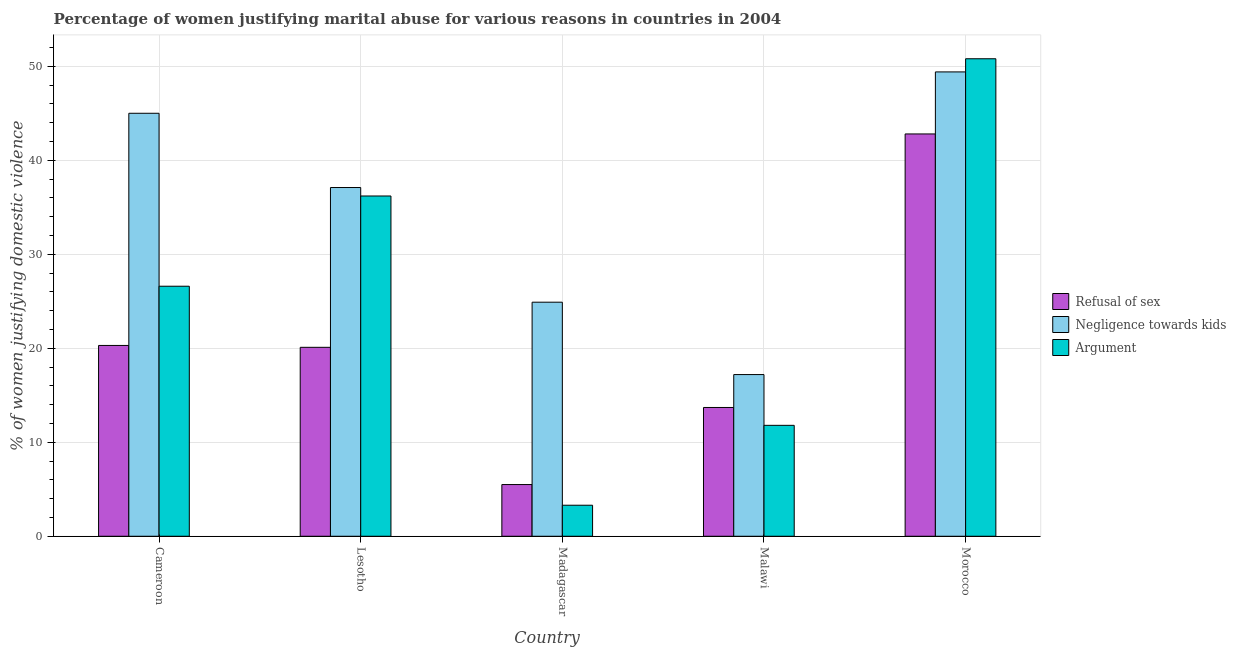How many different coloured bars are there?
Your answer should be compact. 3. How many groups of bars are there?
Ensure brevity in your answer.  5. Are the number of bars on each tick of the X-axis equal?
Your answer should be very brief. Yes. How many bars are there on the 4th tick from the right?
Offer a terse response. 3. What is the label of the 2nd group of bars from the left?
Your answer should be compact. Lesotho. What is the percentage of women justifying domestic violence due to refusal of sex in Morocco?
Give a very brief answer. 42.8. Across all countries, what is the maximum percentage of women justifying domestic violence due to negligence towards kids?
Offer a very short reply. 49.4. In which country was the percentage of women justifying domestic violence due to refusal of sex maximum?
Make the answer very short. Morocco. In which country was the percentage of women justifying domestic violence due to refusal of sex minimum?
Offer a terse response. Madagascar. What is the total percentage of women justifying domestic violence due to negligence towards kids in the graph?
Give a very brief answer. 173.6. What is the difference between the percentage of women justifying domestic violence due to negligence towards kids in Lesotho and that in Malawi?
Your answer should be very brief. 19.9. What is the difference between the percentage of women justifying domestic violence due to negligence towards kids in Lesotho and the percentage of women justifying domestic violence due to refusal of sex in Malawi?
Provide a succinct answer. 23.4. What is the average percentage of women justifying domestic violence due to refusal of sex per country?
Keep it short and to the point. 20.48. In how many countries, is the percentage of women justifying domestic violence due to arguments greater than 50 %?
Your answer should be compact. 1. What is the ratio of the percentage of women justifying domestic violence due to arguments in Lesotho to that in Malawi?
Give a very brief answer. 3.07. What is the difference between the highest and the second highest percentage of women justifying domestic violence due to refusal of sex?
Give a very brief answer. 22.5. What is the difference between the highest and the lowest percentage of women justifying domestic violence due to refusal of sex?
Your answer should be compact. 37.3. In how many countries, is the percentage of women justifying domestic violence due to negligence towards kids greater than the average percentage of women justifying domestic violence due to negligence towards kids taken over all countries?
Provide a succinct answer. 3. Is the sum of the percentage of women justifying domestic violence due to refusal of sex in Madagascar and Morocco greater than the maximum percentage of women justifying domestic violence due to arguments across all countries?
Ensure brevity in your answer.  No. What does the 1st bar from the left in Lesotho represents?
Offer a very short reply. Refusal of sex. What does the 2nd bar from the right in Cameroon represents?
Offer a very short reply. Negligence towards kids. Is it the case that in every country, the sum of the percentage of women justifying domestic violence due to refusal of sex and percentage of women justifying domestic violence due to negligence towards kids is greater than the percentage of women justifying domestic violence due to arguments?
Your answer should be very brief. Yes. How many bars are there?
Ensure brevity in your answer.  15. Are all the bars in the graph horizontal?
Offer a terse response. No. How many countries are there in the graph?
Offer a very short reply. 5. What is the difference between two consecutive major ticks on the Y-axis?
Your response must be concise. 10. Are the values on the major ticks of Y-axis written in scientific E-notation?
Offer a very short reply. No. How many legend labels are there?
Make the answer very short. 3. How are the legend labels stacked?
Provide a short and direct response. Vertical. What is the title of the graph?
Your response must be concise. Percentage of women justifying marital abuse for various reasons in countries in 2004. What is the label or title of the Y-axis?
Provide a succinct answer. % of women justifying domestic violence. What is the % of women justifying domestic violence in Refusal of sex in Cameroon?
Provide a short and direct response. 20.3. What is the % of women justifying domestic violence of Negligence towards kids in Cameroon?
Provide a succinct answer. 45. What is the % of women justifying domestic violence in Argument in Cameroon?
Ensure brevity in your answer.  26.6. What is the % of women justifying domestic violence in Refusal of sex in Lesotho?
Provide a succinct answer. 20.1. What is the % of women justifying domestic violence in Negligence towards kids in Lesotho?
Keep it short and to the point. 37.1. What is the % of women justifying domestic violence of Argument in Lesotho?
Ensure brevity in your answer.  36.2. What is the % of women justifying domestic violence in Refusal of sex in Madagascar?
Ensure brevity in your answer.  5.5. What is the % of women justifying domestic violence of Negligence towards kids in Madagascar?
Your answer should be very brief. 24.9. What is the % of women justifying domestic violence of Refusal of sex in Malawi?
Make the answer very short. 13.7. What is the % of women justifying domestic violence of Negligence towards kids in Malawi?
Offer a terse response. 17.2. What is the % of women justifying domestic violence of Refusal of sex in Morocco?
Give a very brief answer. 42.8. What is the % of women justifying domestic violence of Negligence towards kids in Morocco?
Offer a terse response. 49.4. What is the % of women justifying domestic violence of Argument in Morocco?
Keep it short and to the point. 50.8. Across all countries, what is the maximum % of women justifying domestic violence of Refusal of sex?
Offer a very short reply. 42.8. Across all countries, what is the maximum % of women justifying domestic violence of Negligence towards kids?
Keep it short and to the point. 49.4. Across all countries, what is the maximum % of women justifying domestic violence of Argument?
Offer a terse response. 50.8. Across all countries, what is the minimum % of women justifying domestic violence in Negligence towards kids?
Offer a terse response. 17.2. What is the total % of women justifying domestic violence in Refusal of sex in the graph?
Make the answer very short. 102.4. What is the total % of women justifying domestic violence of Negligence towards kids in the graph?
Your answer should be compact. 173.6. What is the total % of women justifying domestic violence in Argument in the graph?
Your answer should be compact. 128.7. What is the difference between the % of women justifying domestic violence of Refusal of sex in Cameroon and that in Lesotho?
Give a very brief answer. 0.2. What is the difference between the % of women justifying domestic violence of Negligence towards kids in Cameroon and that in Lesotho?
Keep it short and to the point. 7.9. What is the difference between the % of women justifying domestic violence of Argument in Cameroon and that in Lesotho?
Your answer should be compact. -9.6. What is the difference between the % of women justifying domestic violence in Refusal of sex in Cameroon and that in Madagascar?
Offer a very short reply. 14.8. What is the difference between the % of women justifying domestic violence in Negligence towards kids in Cameroon and that in Madagascar?
Make the answer very short. 20.1. What is the difference between the % of women justifying domestic violence of Argument in Cameroon and that in Madagascar?
Your response must be concise. 23.3. What is the difference between the % of women justifying domestic violence in Refusal of sex in Cameroon and that in Malawi?
Keep it short and to the point. 6.6. What is the difference between the % of women justifying domestic violence of Negligence towards kids in Cameroon and that in Malawi?
Your answer should be compact. 27.8. What is the difference between the % of women justifying domestic violence in Argument in Cameroon and that in Malawi?
Provide a short and direct response. 14.8. What is the difference between the % of women justifying domestic violence in Refusal of sex in Cameroon and that in Morocco?
Make the answer very short. -22.5. What is the difference between the % of women justifying domestic violence of Negligence towards kids in Cameroon and that in Morocco?
Offer a terse response. -4.4. What is the difference between the % of women justifying domestic violence in Argument in Cameroon and that in Morocco?
Ensure brevity in your answer.  -24.2. What is the difference between the % of women justifying domestic violence in Refusal of sex in Lesotho and that in Madagascar?
Provide a succinct answer. 14.6. What is the difference between the % of women justifying domestic violence of Argument in Lesotho and that in Madagascar?
Provide a succinct answer. 32.9. What is the difference between the % of women justifying domestic violence in Argument in Lesotho and that in Malawi?
Give a very brief answer. 24.4. What is the difference between the % of women justifying domestic violence of Refusal of sex in Lesotho and that in Morocco?
Ensure brevity in your answer.  -22.7. What is the difference between the % of women justifying domestic violence of Negligence towards kids in Lesotho and that in Morocco?
Your response must be concise. -12.3. What is the difference between the % of women justifying domestic violence of Argument in Lesotho and that in Morocco?
Your answer should be very brief. -14.6. What is the difference between the % of women justifying domestic violence in Refusal of sex in Madagascar and that in Malawi?
Give a very brief answer. -8.2. What is the difference between the % of women justifying domestic violence in Negligence towards kids in Madagascar and that in Malawi?
Ensure brevity in your answer.  7.7. What is the difference between the % of women justifying domestic violence of Refusal of sex in Madagascar and that in Morocco?
Provide a succinct answer. -37.3. What is the difference between the % of women justifying domestic violence of Negligence towards kids in Madagascar and that in Morocco?
Your response must be concise. -24.5. What is the difference between the % of women justifying domestic violence of Argument in Madagascar and that in Morocco?
Keep it short and to the point. -47.5. What is the difference between the % of women justifying domestic violence in Refusal of sex in Malawi and that in Morocco?
Your answer should be very brief. -29.1. What is the difference between the % of women justifying domestic violence of Negligence towards kids in Malawi and that in Morocco?
Offer a terse response. -32.2. What is the difference between the % of women justifying domestic violence of Argument in Malawi and that in Morocco?
Offer a very short reply. -39. What is the difference between the % of women justifying domestic violence of Refusal of sex in Cameroon and the % of women justifying domestic violence of Negligence towards kids in Lesotho?
Offer a terse response. -16.8. What is the difference between the % of women justifying domestic violence of Refusal of sex in Cameroon and the % of women justifying domestic violence of Argument in Lesotho?
Provide a succinct answer. -15.9. What is the difference between the % of women justifying domestic violence in Refusal of sex in Cameroon and the % of women justifying domestic violence in Negligence towards kids in Madagascar?
Offer a terse response. -4.6. What is the difference between the % of women justifying domestic violence of Negligence towards kids in Cameroon and the % of women justifying domestic violence of Argument in Madagascar?
Your answer should be very brief. 41.7. What is the difference between the % of women justifying domestic violence of Negligence towards kids in Cameroon and the % of women justifying domestic violence of Argument in Malawi?
Your answer should be very brief. 33.2. What is the difference between the % of women justifying domestic violence in Refusal of sex in Cameroon and the % of women justifying domestic violence in Negligence towards kids in Morocco?
Provide a short and direct response. -29.1. What is the difference between the % of women justifying domestic violence in Refusal of sex in Cameroon and the % of women justifying domestic violence in Argument in Morocco?
Offer a very short reply. -30.5. What is the difference between the % of women justifying domestic violence in Negligence towards kids in Lesotho and the % of women justifying domestic violence in Argument in Madagascar?
Provide a succinct answer. 33.8. What is the difference between the % of women justifying domestic violence of Refusal of sex in Lesotho and the % of women justifying domestic violence of Negligence towards kids in Malawi?
Offer a very short reply. 2.9. What is the difference between the % of women justifying domestic violence of Negligence towards kids in Lesotho and the % of women justifying domestic violence of Argument in Malawi?
Provide a short and direct response. 25.3. What is the difference between the % of women justifying domestic violence of Refusal of sex in Lesotho and the % of women justifying domestic violence of Negligence towards kids in Morocco?
Your response must be concise. -29.3. What is the difference between the % of women justifying domestic violence in Refusal of sex in Lesotho and the % of women justifying domestic violence in Argument in Morocco?
Keep it short and to the point. -30.7. What is the difference between the % of women justifying domestic violence in Negligence towards kids in Lesotho and the % of women justifying domestic violence in Argument in Morocco?
Give a very brief answer. -13.7. What is the difference between the % of women justifying domestic violence of Refusal of sex in Madagascar and the % of women justifying domestic violence of Negligence towards kids in Morocco?
Provide a succinct answer. -43.9. What is the difference between the % of women justifying domestic violence of Refusal of sex in Madagascar and the % of women justifying domestic violence of Argument in Morocco?
Your answer should be compact. -45.3. What is the difference between the % of women justifying domestic violence in Negligence towards kids in Madagascar and the % of women justifying domestic violence in Argument in Morocco?
Your answer should be compact. -25.9. What is the difference between the % of women justifying domestic violence in Refusal of sex in Malawi and the % of women justifying domestic violence in Negligence towards kids in Morocco?
Your response must be concise. -35.7. What is the difference between the % of women justifying domestic violence in Refusal of sex in Malawi and the % of women justifying domestic violence in Argument in Morocco?
Your answer should be very brief. -37.1. What is the difference between the % of women justifying domestic violence of Negligence towards kids in Malawi and the % of women justifying domestic violence of Argument in Morocco?
Give a very brief answer. -33.6. What is the average % of women justifying domestic violence of Refusal of sex per country?
Provide a succinct answer. 20.48. What is the average % of women justifying domestic violence in Negligence towards kids per country?
Provide a succinct answer. 34.72. What is the average % of women justifying domestic violence of Argument per country?
Offer a terse response. 25.74. What is the difference between the % of women justifying domestic violence in Refusal of sex and % of women justifying domestic violence in Negligence towards kids in Cameroon?
Provide a short and direct response. -24.7. What is the difference between the % of women justifying domestic violence in Refusal of sex and % of women justifying domestic violence in Argument in Cameroon?
Make the answer very short. -6.3. What is the difference between the % of women justifying domestic violence of Refusal of sex and % of women justifying domestic violence of Negligence towards kids in Lesotho?
Ensure brevity in your answer.  -17. What is the difference between the % of women justifying domestic violence in Refusal of sex and % of women justifying domestic violence in Argument in Lesotho?
Ensure brevity in your answer.  -16.1. What is the difference between the % of women justifying domestic violence of Negligence towards kids and % of women justifying domestic violence of Argument in Lesotho?
Offer a terse response. 0.9. What is the difference between the % of women justifying domestic violence of Refusal of sex and % of women justifying domestic violence of Negligence towards kids in Madagascar?
Keep it short and to the point. -19.4. What is the difference between the % of women justifying domestic violence in Negligence towards kids and % of women justifying domestic violence in Argument in Madagascar?
Your response must be concise. 21.6. What is the difference between the % of women justifying domestic violence in Refusal of sex and % of women justifying domestic violence in Negligence towards kids in Morocco?
Keep it short and to the point. -6.6. What is the difference between the % of women justifying domestic violence of Negligence towards kids and % of women justifying domestic violence of Argument in Morocco?
Your answer should be compact. -1.4. What is the ratio of the % of women justifying domestic violence of Negligence towards kids in Cameroon to that in Lesotho?
Your answer should be compact. 1.21. What is the ratio of the % of women justifying domestic violence in Argument in Cameroon to that in Lesotho?
Your answer should be compact. 0.73. What is the ratio of the % of women justifying domestic violence of Refusal of sex in Cameroon to that in Madagascar?
Your response must be concise. 3.69. What is the ratio of the % of women justifying domestic violence of Negligence towards kids in Cameroon to that in Madagascar?
Offer a terse response. 1.81. What is the ratio of the % of women justifying domestic violence of Argument in Cameroon to that in Madagascar?
Make the answer very short. 8.06. What is the ratio of the % of women justifying domestic violence in Refusal of sex in Cameroon to that in Malawi?
Keep it short and to the point. 1.48. What is the ratio of the % of women justifying domestic violence in Negligence towards kids in Cameroon to that in Malawi?
Ensure brevity in your answer.  2.62. What is the ratio of the % of women justifying domestic violence in Argument in Cameroon to that in Malawi?
Make the answer very short. 2.25. What is the ratio of the % of women justifying domestic violence of Refusal of sex in Cameroon to that in Morocco?
Your answer should be very brief. 0.47. What is the ratio of the % of women justifying domestic violence in Negligence towards kids in Cameroon to that in Morocco?
Your response must be concise. 0.91. What is the ratio of the % of women justifying domestic violence of Argument in Cameroon to that in Morocco?
Make the answer very short. 0.52. What is the ratio of the % of women justifying domestic violence of Refusal of sex in Lesotho to that in Madagascar?
Your answer should be very brief. 3.65. What is the ratio of the % of women justifying domestic violence in Negligence towards kids in Lesotho to that in Madagascar?
Offer a very short reply. 1.49. What is the ratio of the % of women justifying domestic violence in Argument in Lesotho to that in Madagascar?
Your answer should be very brief. 10.97. What is the ratio of the % of women justifying domestic violence of Refusal of sex in Lesotho to that in Malawi?
Your answer should be very brief. 1.47. What is the ratio of the % of women justifying domestic violence in Negligence towards kids in Lesotho to that in Malawi?
Make the answer very short. 2.16. What is the ratio of the % of women justifying domestic violence of Argument in Lesotho to that in Malawi?
Your answer should be very brief. 3.07. What is the ratio of the % of women justifying domestic violence of Refusal of sex in Lesotho to that in Morocco?
Make the answer very short. 0.47. What is the ratio of the % of women justifying domestic violence of Negligence towards kids in Lesotho to that in Morocco?
Make the answer very short. 0.75. What is the ratio of the % of women justifying domestic violence in Argument in Lesotho to that in Morocco?
Your answer should be compact. 0.71. What is the ratio of the % of women justifying domestic violence of Refusal of sex in Madagascar to that in Malawi?
Your answer should be compact. 0.4. What is the ratio of the % of women justifying domestic violence in Negligence towards kids in Madagascar to that in Malawi?
Ensure brevity in your answer.  1.45. What is the ratio of the % of women justifying domestic violence in Argument in Madagascar to that in Malawi?
Give a very brief answer. 0.28. What is the ratio of the % of women justifying domestic violence in Refusal of sex in Madagascar to that in Morocco?
Keep it short and to the point. 0.13. What is the ratio of the % of women justifying domestic violence in Negligence towards kids in Madagascar to that in Morocco?
Ensure brevity in your answer.  0.5. What is the ratio of the % of women justifying domestic violence of Argument in Madagascar to that in Morocco?
Your response must be concise. 0.07. What is the ratio of the % of women justifying domestic violence of Refusal of sex in Malawi to that in Morocco?
Ensure brevity in your answer.  0.32. What is the ratio of the % of women justifying domestic violence of Negligence towards kids in Malawi to that in Morocco?
Give a very brief answer. 0.35. What is the ratio of the % of women justifying domestic violence in Argument in Malawi to that in Morocco?
Make the answer very short. 0.23. What is the difference between the highest and the second highest % of women justifying domestic violence in Refusal of sex?
Provide a succinct answer. 22.5. What is the difference between the highest and the second highest % of women justifying domestic violence in Argument?
Your response must be concise. 14.6. What is the difference between the highest and the lowest % of women justifying domestic violence in Refusal of sex?
Offer a very short reply. 37.3. What is the difference between the highest and the lowest % of women justifying domestic violence of Negligence towards kids?
Make the answer very short. 32.2. What is the difference between the highest and the lowest % of women justifying domestic violence of Argument?
Make the answer very short. 47.5. 